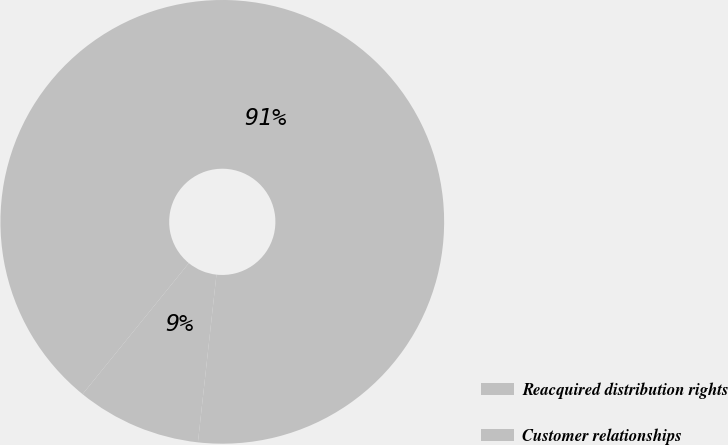Convert chart to OTSL. <chart><loc_0><loc_0><loc_500><loc_500><pie_chart><fcel>Reacquired distribution rights<fcel>Customer relationships<nl><fcel>9.09%<fcel>90.91%<nl></chart> 